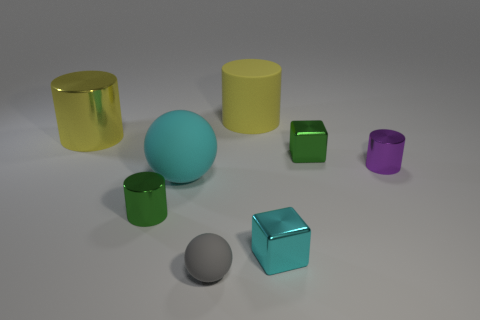Can you describe the colors and shapes of the objects in this image? Certainly! The image contains a variety of shapes and colors. There is a large yellow cylinder, a teal cube, a large green cylinder, and a small green one, a matte cyan sphere, a small purple cylinder, and a small gray sphere. Each object has a distinct, matte finish, and they are arranged on a flat surface with soft lighting.  Which object seems closest to the camera? The object closest to the camera appears to be the small gray sphere. It's positioned in the foreground, making it appear prominent in the scene. 